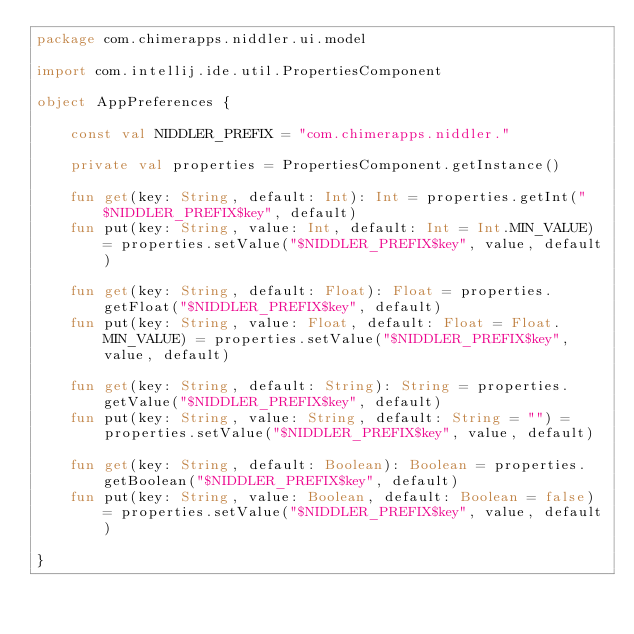Convert code to text. <code><loc_0><loc_0><loc_500><loc_500><_Kotlin_>package com.chimerapps.niddler.ui.model

import com.intellij.ide.util.PropertiesComponent

object AppPreferences {

    const val NIDDLER_PREFIX = "com.chimerapps.niddler."

    private val properties = PropertiesComponent.getInstance()

    fun get(key: String, default: Int): Int = properties.getInt("$NIDDLER_PREFIX$key", default)
    fun put(key: String, value: Int, default: Int = Int.MIN_VALUE) = properties.setValue("$NIDDLER_PREFIX$key", value, default)

    fun get(key: String, default: Float): Float = properties.getFloat("$NIDDLER_PREFIX$key", default)
    fun put(key: String, value: Float, default: Float = Float.MIN_VALUE) = properties.setValue("$NIDDLER_PREFIX$key", value, default)

    fun get(key: String, default: String): String = properties.getValue("$NIDDLER_PREFIX$key", default)
    fun put(key: String, value: String, default: String = "") = properties.setValue("$NIDDLER_PREFIX$key", value, default)

    fun get(key: String, default: Boolean): Boolean = properties.getBoolean("$NIDDLER_PREFIX$key", default)
    fun put(key: String, value: Boolean, default: Boolean = false) = properties.setValue("$NIDDLER_PREFIX$key", value, default)

}</code> 